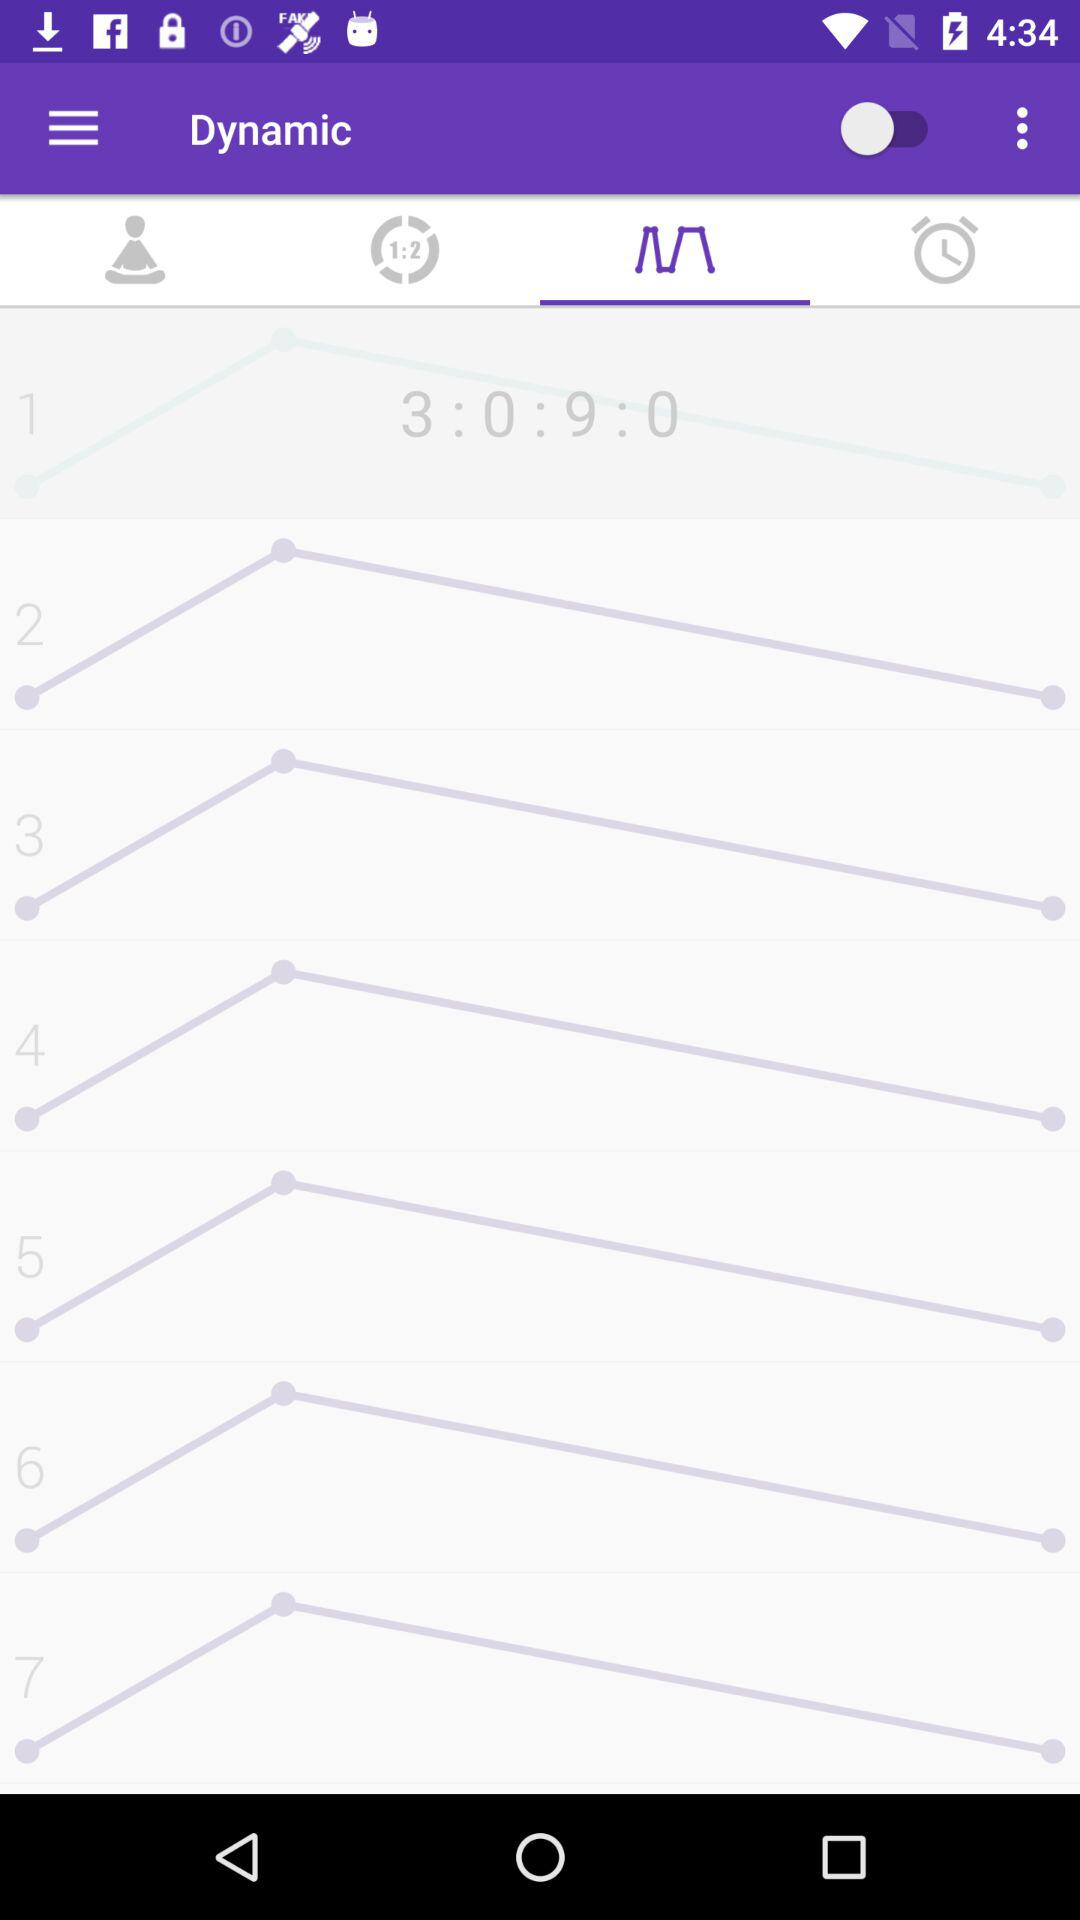What is the status of "Dynamic"? The status is "off". 